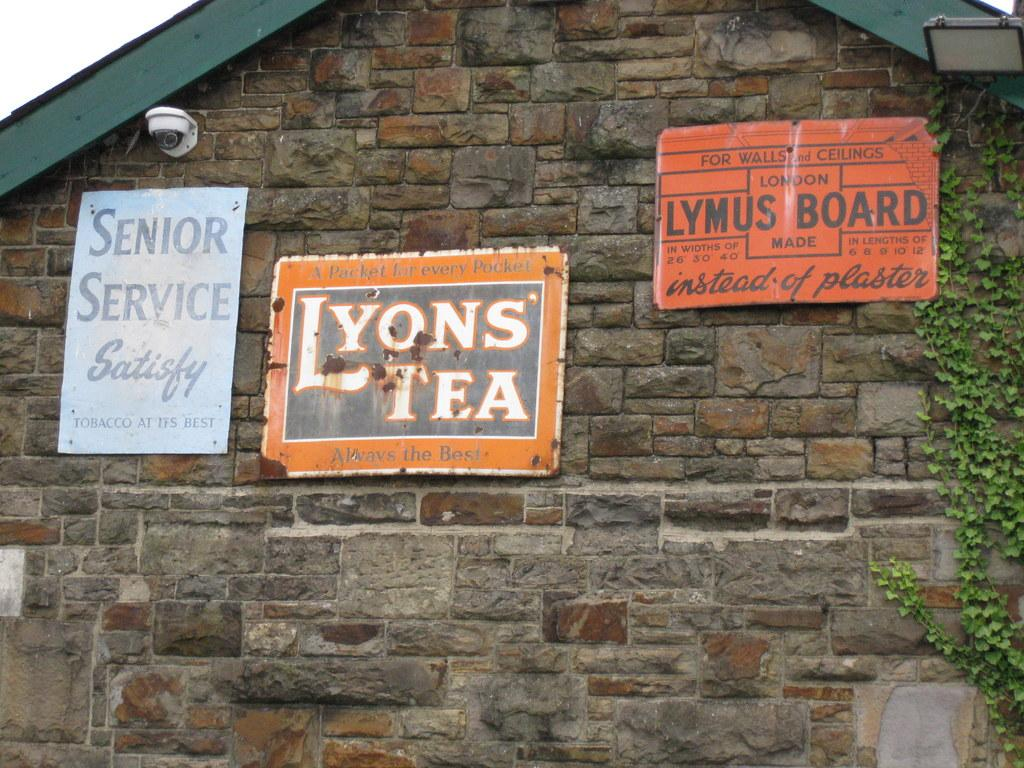What is the main feature in the foreground of the picture? There is a brick wall in the foreground of the picture. What is attached to the brick wall? There are boards and a creeper on the wall. What device is also present on the wall? There is a camera on the wall. What type of fuel is being used by the servant in the image? There is no servant or fuel present in the image. How does the creeper move around on the wall in the image? The creeper does not move around on the wall in the image; it is stationary. 